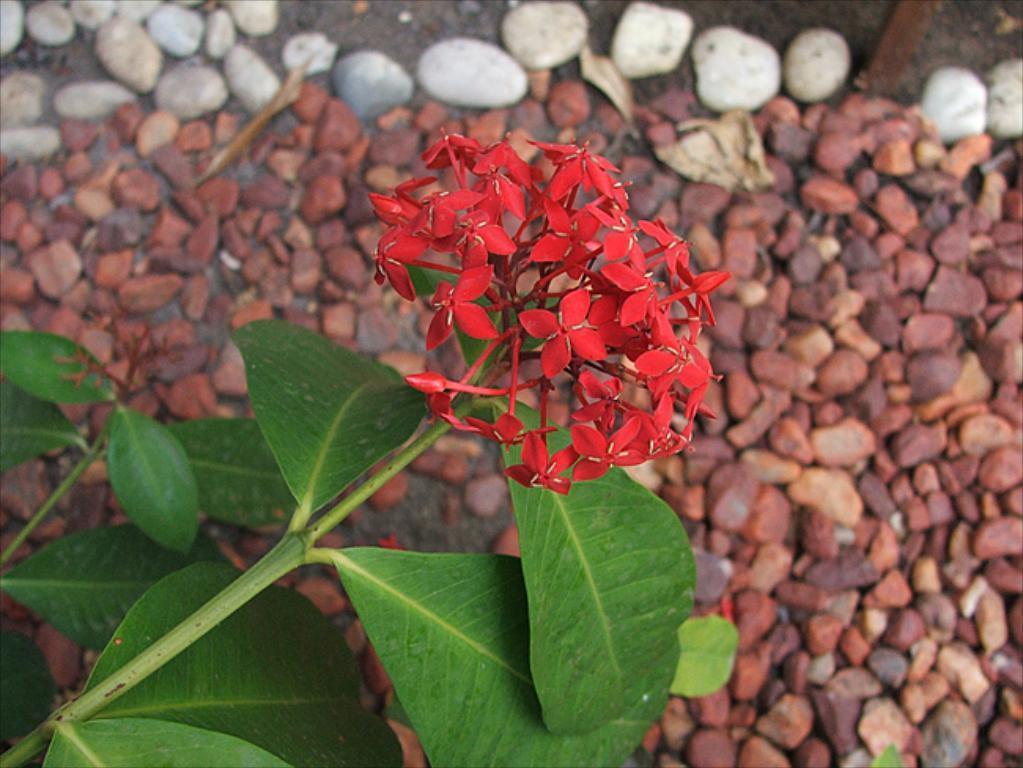Could you give a brief overview of what you see in this image? In this picture we can see flowers, leaves and on the ground we can see stones. 